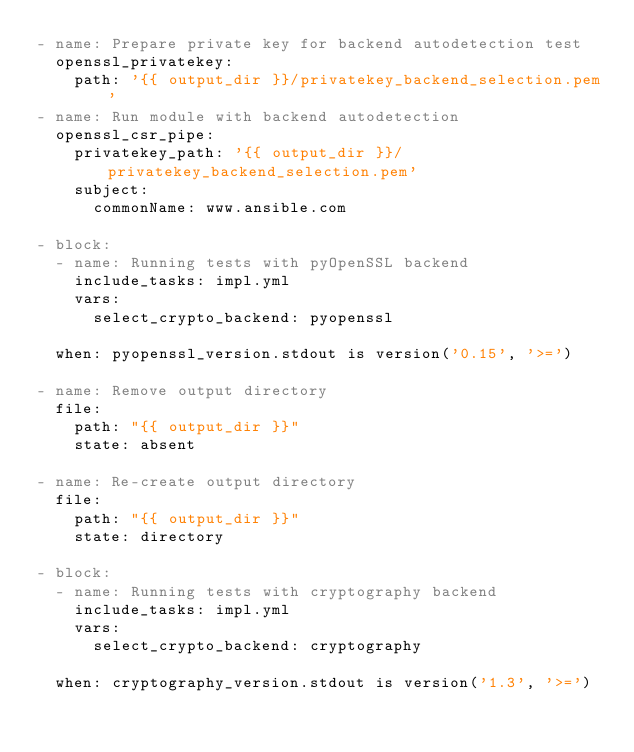Convert code to text. <code><loc_0><loc_0><loc_500><loc_500><_YAML_>- name: Prepare private key for backend autodetection test
  openssl_privatekey:
    path: '{{ output_dir }}/privatekey_backend_selection.pem'
- name: Run module with backend autodetection
  openssl_csr_pipe:
    privatekey_path: '{{ output_dir }}/privatekey_backend_selection.pem'
    subject:
      commonName: www.ansible.com

- block:
  - name: Running tests with pyOpenSSL backend
    include_tasks: impl.yml
    vars:
      select_crypto_backend: pyopenssl

  when: pyopenssl_version.stdout is version('0.15', '>=')

- name: Remove output directory
  file:
    path: "{{ output_dir }}"
    state: absent

- name: Re-create output directory
  file:
    path: "{{ output_dir }}"
    state: directory

- block:
  - name: Running tests with cryptography backend
    include_tasks: impl.yml
    vars:
      select_crypto_backend: cryptography

  when: cryptography_version.stdout is version('1.3', '>=')
</code> 